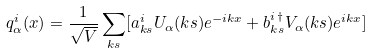<formula> <loc_0><loc_0><loc_500><loc_500>q _ { \alpha } ^ { i } ( x ) = \frac { 1 } { \sqrt { V } } \sum _ { k s } [ a _ { k s } ^ { i } U _ { \alpha } ( k s ) e ^ { - i k x } + b _ { k s } ^ { i \, \dagger } V _ { \alpha } ( k s ) e ^ { i k x } ]</formula> 